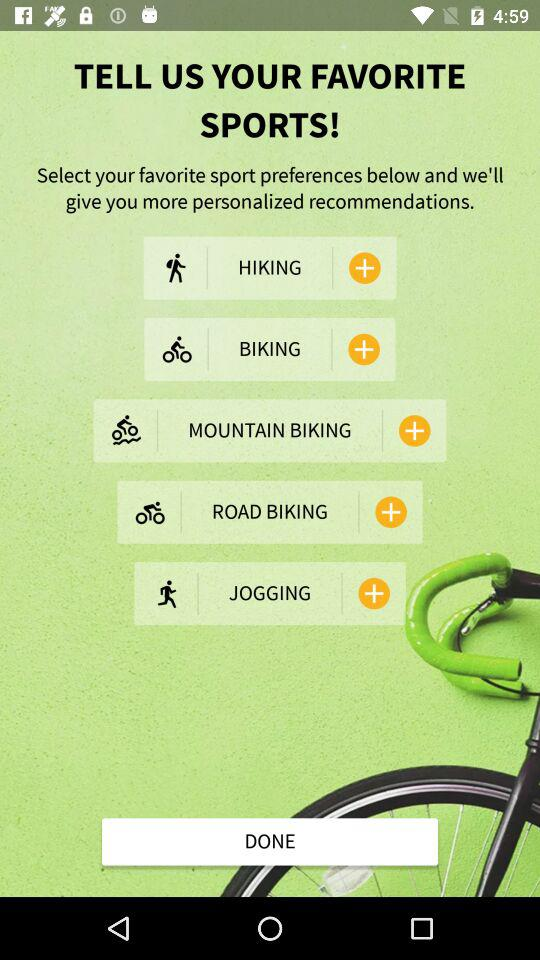What are the sports options that I can select? The sports options that you can select are "HIKING", "BIKING", "MOUNTAIN BIKING", "ROAD BIKING" and "JOGGING". 